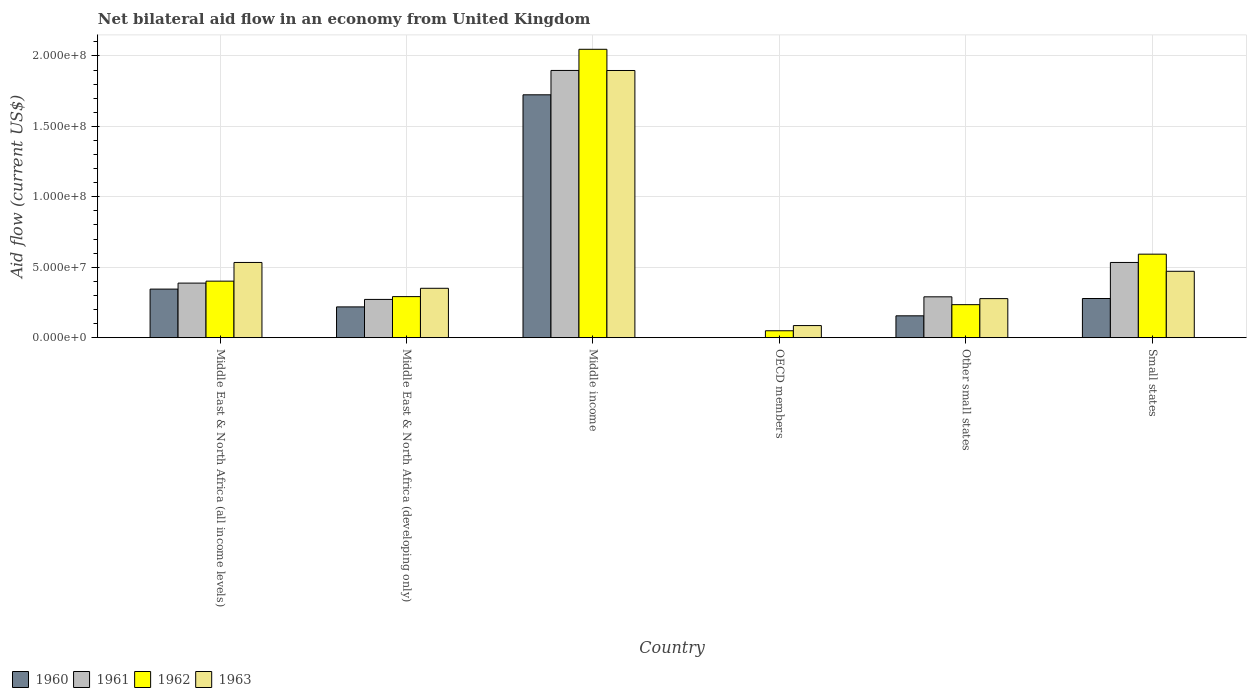How many groups of bars are there?
Offer a very short reply. 6. How many bars are there on the 2nd tick from the left?
Offer a terse response. 4. What is the label of the 4th group of bars from the left?
Your response must be concise. OECD members. In how many cases, is the number of bars for a given country not equal to the number of legend labels?
Make the answer very short. 1. What is the net bilateral aid flow in 1961 in OECD members?
Make the answer very short. 0. Across all countries, what is the maximum net bilateral aid flow in 1961?
Make the answer very short. 1.90e+08. Across all countries, what is the minimum net bilateral aid flow in 1962?
Provide a succinct answer. 4.90e+06. What is the total net bilateral aid flow in 1960 in the graph?
Give a very brief answer. 2.72e+08. What is the difference between the net bilateral aid flow in 1963 in Middle East & North Africa (developing only) and that in Middle income?
Your response must be concise. -1.55e+08. What is the difference between the net bilateral aid flow in 1960 in Middle East & North Africa (all income levels) and the net bilateral aid flow in 1963 in Middle East & North Africa (developing only)?
Your answer should be very brief. -5.80e+05. What is the average net bilateral aid flow in 1960 per country?
Ensure brevity in your answer.  4.53e+07. What is the difference between the net bilateral aid flow of/in 1962 and net bilateral aid flow of/in 1960 in Middle East & North Africa (developing only)?
Offer a terse response. 7.30e+06. What is the ratio of the net bilateral aid flow in 1960 in Middle East & North Africa (all income levels) to that in Other small states?
Your answer should be very brief. 2.22. What is the difference between the highest and the second highest net bilateral aid flow in 1961?
Keep it short and to the point. 1.51e+08. What is the difference between the highest and the lowest net bilateral aid flow in 1962?
Your answer should be compact. 2.00e+08. Is the sum of the net bilateral aid flow in 1963 in Middle income and Small states greater than the maximum net bilateral aid flow in 1961 across all countries?
Your answer should be compact. Yes. Is it the case that in every country, the sum of the net bilateral aid flow in 1963 and net bilateral aid flow in 1961 is greater than the sum of net bilateral aid flow in 1962 and net bilateral aid flow in 1960?
Your answer should be compact. No. How many countries are there in the graph?
Your answer should be compact. 6. What is the difference between two consecutive major ticks on the Y-axis?
Your response must be concise. 5.00e+07. Are the values on the major ticks of Y-axis written in scientific E-notation?
Give a very brief answer. Yes. Does the graph contain any zero values?
Offer a very short reply. Yes. Where does the legend appear in the graph?
Your response must be concise. Bottom left. How are the legend labels stacked?
Offer a very short reply. Horizontal. What is the title of the graph?
Make the answer very short. Net bilateral aid flow in an economy from United Kingdom. Does "1970" appear as one of the legend labels in the graph?
Keep it short and to the point. No. What is the label or title of the Y-axis?
Provide a short and direct response. Aid flow (current US$). What is the Aid flow (current US$) in 1960 in Middle East & North Africa (all income levels)?
Your response must be concise. 3.45e+07. What is the Aid flow (current US$) in 1961 in Middle East & North Africa (all income levels)?
Provide a succinct answer. 3.87e+07. What is the Aid flow (current US$) in 1962 in Middle East & North Africa (all income levels)?
Keep it short and to the point. 4.01e+07. What is the Aid flow (current US$) in 1963 in Middle East & North Africa (all income levels)?
Keep it short and to the point. 5.34e+07. What is the Aid flow (current US$) in 1960 in Middle East & North Africa (developing only)?
Provide a succinct answer. 2.18e+07. What is the Aid flow (current US$) in 1961 in Middle East & North Africa (developing only)?
Your answer should be very brief. 2.72e+07. What is the Aid flow (current US$) of 1962 in Middle East & North Africa (developing only)?
Provide a succinct answer. 2.91e+07. What is the Aid flow (current US$) of 1963 in Middle East & North Africa (developing only)?
Provide a short and direct response. 3.50e+07. What is the Aid flow (current US$) in 1960 in Middle income?
Offer a very short reply. 1.72e+08. What is the Aid flow (current US$) in 1961 in Middle income?
Your response must be concise. 1.90e+08. What is the Aid flow (current US$) of 1962 in Middle income?
Your answer should be very brief. 2.05e+08. What is the Aid flow (current US$) in 1963 in Middle income?
Offer a very short reply. 1.90e+08. What is the Aid flow (current US$) of 1960 in OECD members?
Ensure brevity in your answer.  0. What is the Aid flow (current US$) of 1962 in OECD members?
Offer a terse response. 4.90e+06. What is the Aid flow (current US$) in 1963 in OECD members?
Offer a terse response. 8.59e+06. What is the Aid flow (current US$) in 1960 in Other small states?
Give a very brief answer. 1.55e+07. What is the Aid flow (current US$) of 1961 in Other small states?
Keep it short and to the point. 2.90e+07. What is the Aid flow (current US$) of 1962 in Other small states?
Keep it short and to the point. 2.34e+07. What is the Aid flow (current US$) of 1963 in Other small states?
Give a very brief answer. 2.77e+07. What is the Aid flow (current US$) in 1960 in Small states?
Your response must be concise. 2.78e+07. What is the Aid flow (current US$) of 1961 in Small states?
Your answer should be compact. 5.34e+07. What is the Aid flow (current US$) of 1962 in Small states?
Your response must be concise. 5.93e+07. What is the Aid flow (current US$) of 1963 in Small states?
Your response must be concise. 4.71e+07. Across all countries, what is the maximum Aid flow (current US$) in 1960?
Provide a succinct answer. 1.72e+08. Across all countries, what is the maximum Aid flow (current US$) of 1961?
Your answer should be compact. 1.90e+08. Across all countries, what is the maximum Aid flow (current US$) of 1962?
Your response must be concise. 2.05e+08. Across all countries, what is the maximum Aid flow (current US$) in 1963?
Provide a short and direct response. 1.90e+08. Across all countries, what is the minimum Aid flow (current US$) in 1961?
Keep it short and to the point. 0. Across all countries, what is the minimum Aid flow (current US$) in 1962?
Provide a short and direct response. 4.90e+06. Across all countries, what is the minimum Aid flow (current US$) in 1963?
Make the answer very short. 8.59e+06. What is the total Aid flow (current US$) in 1960 in the graph?
Give a very brief answer. 2.72e+08. What is the total Aid flow (current US$) in 1961 in the graph?
Offer a very short reply. 3.38e+08. What is the total Aid flow (current US$) in 1962 in the graph?
Your answer should be compact. 3.62e+08. What is the total Aid flow (current US$) of 1963 in the graph?
Give a very brief answer. 3.62e+08. What is the difference between the Aid flow (current US$) of 1960 in Middle East & North Africa (all income levels) and that in Middle East & North Africa (developing only)?
Your answer should be very brief. 1.26e+07. What is the difference between the Aid flow (current US$) in 1961 in Middle East & North Africa (all income levels) and that in Middle East & North Africa (developing only)?
Your answer should be very brief. 1.16e+07. What is the difference between the Aid flow (current US$) of 1962 in Middle East & North Africa (all income levels) and that in Middle East & North Africa (developing only)?
Provide a short and direct response. 1.10e+07. What is the difference between the Aid flow (current US$) in 1963 in Middle East & North Africa (all income levels) and that in Middle East & North Africa (developing only)?
Make the answer very short. 1.83e+07. What is the difference between the Aid flow (current US$) in 1960 in Middle East & North Africa (all income levels) and that in Middle income?
Your answer should be very brief. -1.38e+08. What is the difference between the Aid flow (current US$) in 1961 in Middle East & North Africa (all income levels) and that in Middle income?
Offer a terse response. -1.51e+08. What is the difference between the Aid flow (current US$) in 1962 in Middle East & North Africa (all income levels) and that in Middle income?
Offer a terse response. -1.65e+08. What is the difference between the Aid flow (current US$) in 1963 in Middle East & North Africa (all income levels) and that in Middle income?
Your response must be concise. -1.36e+08. What is the difference between the Aid flow (current US$) in 1962 in Middle East & North Africa (all income levels) and that in OECD members?
Offer a terse response. 3.52e+07. What is the difference between the Aid flow (current US$) in 1963 in Middle East & North Africa (all income levels) and that in OECD members?
Your answer should be compact. 4.48e+07. What is the difference between the Aid flow (current US$) in 1960 in Middle East & North Africa (all income levels) and that in Other small states?
Offer a terse response. 1.90e+07. What is the difference between the Aid flow (current US$) in 1961 in Middle East & North Africa (all income levels) and that in Other small states?
Your response must be concise. 9.74e+06. What is the difference between the Aid flow (current US$) of 1962 in Middle East & North Africa (all income levels) and that in Other small states?
Your response must be concise. 1.67e+07. What is the difference between the Aid flow (current US$) in 1963 in Middle East & North Africa (all income levels) and that in Other small states?
Keep it short and to the point. 2.57e+07. What is the difference between the Aid flow (current US$) in 1960 in Middle East & North Africa (all income levels) and that in Small states?
Provide a short and direct response. 6.67e+06. What is the difference between the Aid flow (current US$) of 1961 in Middle East & North Africa (all income levels) and that in Small states?
Give a very brief answer. -1.46e+07. What is the difference between the Aid flow (current US$) of 1962 in Middle East & North Africa (all income levels) and that in Small states?
Make the answer very short. -1.92e+07. What is the difference between the Aid flow (current US$) of 1963 in Middle East & North Africa (all income levels) and that in Small states?
Your response must be concise. 6.26e+06. What is the difference between the Aid flow (current US$) in 1960 in Middle East & North Africa (developing only) and that in Middle income?
Give a very brief answer. -1.51e+08. What is the difference between the Aid flow (current US$) of 1961 in Middle East & North Africa (developing only) and that in Middle income?
Your response must be concise. -1.63e+08. What is the difference between the Aid flow (current US$) of 1962 in Middle East & North Africa (developing only) and that in Middle income?
Offer a very short reply. -1.76e+08. What is the difference between the Aid flow (current US$) in 1963 in Middle East & North Africa (developing only) and that in Middle income?
Offer a very short reply. -1.55e+08. What is the difference between the Aid flow (current US$) of 1962 in Middle East & North Africa (developing only) and that in OECD members?
Provide a succinct answer. 2.42e+07. What is the difference between the Aid flow (current US$) in 1963 in Middle East & North Africa (developing only) and that in OECD members?
Keep it short and to the point. 2.65e+07. What is the difference between the Aid flow (current US$) in 1960 in Middle East & North Africa (developing only) and that in Other small states?
Provide a succinct answer. 6.33e+06. What is the difference between the Aid flow (current US$) in 1961 in Middle East & North Africa (developing only) and that in Other small states?
Your response must be concise. -1.84e+06. What is the difference between the Aid flow (current US$) of 1962 in Middle East & North Africa (developing only) and that in Other small states?
Provide a short and direct response. 5.71e+06. What is the difference between the Aid flow (current US$) of 1963 in Middle East & North Africa (developing only) and that in Other small states?
Give a very brief answer. 7.33e+06. What is the difference between the Aid flow (current US$) of 1960 in Middle East & North Africa (developing only) and that in Small states?
Offer a very short reply. -5.96e+06. What is the difference between the Aid flow (current US$) in 1961 in Middle East & North Africa (developing only) and that in Small states?
Your response must be concise. -2.62e+07. What is the difference between the Aid flow (current US$) of 1962 in Middle East & North Africa (developing only) and that in Small states?
Ensure brevity in your answer.  -3.01e+07. What is the difference between the Aid flow (current US$) in 1963 in Middle East & North Africa (developing only) and that in Small states?
Provide a succinct answer. -1.21e+07. What is the difference between the Aid flow (current US$) in 1962 in Middle income and that in OECD members?
Offer a terse response. 2.00e+08. What is the difference between the Aid flow (current US$) in 1963 in Middle income and that in OECD members?
Your answer should be very brief. 1.81e+08. What is the difference between the Aid flow (current US$) of 1960 in Middle income and that in Other small states?
Ensure brevity in your answer.  1.57e+08. What is the difference between the Aid flow (current US$) in 1961 in Middle income and that in Other small states?
Give a very brief answer. 1.61e+08. What is the difference between the Aid flow (current US$) in 1962 in Middle income and that in Other small states?
Offer a very short reply. 1.81e+08. What is the difference between the Aid flow (current US$) in 1963 in Middle income and that in Other small states?
Keep it short and to the point. 1.62e+08. What is the difference between the Aid flow (current US$) of 1960 in Middle income and that in Small states?
Your answer should be very brief. 1.45e+08. What is the difference between the Aid flow (current US$) of 1961 in Middle income and that in Small states?
Your response must be concise. 1.36e+08. What is the difference between the Aid flow (current US$) in 1962 in Middle income and that in Small states?
Ensure brevity in your answer.  1.45e+08. What is the difference between the Aid flow (current US$) in 1963 in Middle income and that in Small states?
Give a very brief answer. 1.43e+08. What is the difference between the Aid flow (current US$) in 1962 in OECD members and that in Other small states?
Offer a very short reply. -1.85e+07. What is the difference between the Aid flow (current US$) in 1963 in OECD members and that in Other small states?
Keep it short and to the point. -1.91e+07. What is the difference between the Aid flow (current US$) of 1962 in OECD members and that in Small states?
Provide a succinct answer. -5.44e+07. What is the difference between the Aid flow (current US$) of 1963 in OECD members and that in Small states?
Your answer should be compact. -3.85e+07. What is the difference between the Aid flow (current US$) of 1960 in Other small states and that in Small states?
Provide a short and direct response. -1.23e+07. What is the difference between the Aid flow (current US$) in 1961 in Other small states and that in Small states?
Ensure brevity in your answer.  -2.44e+07. What is the difference between the Aid flow (current US$) of 1962 in Other small states and that in Small states?
Provide a short and direct response. -3.58e+07. What is the difference between the Aid flow (current US$) of 1963 in Other small states and that in Small states?
Provide a short and direct response. -1.94e+07. What is the difference between the Aid flow (current US$) in 1960 in Middle East & North Africa (all income levels) and the Aid flow (current US$) in 1961 in Middle East & North Africa (developing only)?
Provide a short and direct response. 7.32e+06. What is the difference between the Aid flow (current US$) in 1960 in Middle East & North Africa (all income levels) and the Aid flow (current US$) in 1962 in Middle East & North Africa (developing only)?
Offer a terse response. 5.33e+06. What is the difference between the Aid flow (current US$) of 1960 in Middle East & North Africa (all income levels) and the Aid flow (current US$) of 1963 in Middle East & North Africa (developing only)?
Your answer should be very brief. -5.80e+05. What is the difference between the Aid flow (current US$) in 1961 in Middle East & North Africa (all income levels) and the Aid flow (current US$) in 1962 in Middle East & North Africa (developing only)?
Ensure brevity in your answer.  9.59e+06. What is the difference between the Aid flow (current US$) in 1961 in Middle East & North Africa (all income levels) and the Aid flow (current US$) in 1963 in Middle East & North Africa (developing only)?
Keep it short and to the point. 3.68e+06. What is the difference between the Aid flow (current US$) in 1962 in Middle East & North Africa (all income levels) and the Aid flow (current US$) in 1963 in Middle East & North Africa (developing only)?
Provide a succinct answer. 5.07e+06. What is the difference between the Aid flow (current US$) in 1960 in Middle East & North Africa (all income levels) and the Aid flow (current US$) in 1961 in Middle income?
Provide a succinct answer. -1.55e+08. What is the difference between the Aid flow (current US$) in 1960 in Middle East & North Africa (all income levels) and the Aid flow (current US$) in 1962 in Middle income?
Provide a succinct answer. -1.70e+08. What is the difference between the Aid flow (current US$) of 1960 in Middle East & North Africa (all income levels) and the Aid flow (current US$) of 1963 in Middle income?
Offer a very short reply. -1.55e+08. What is the difference between the Aid flow (current US$) in 1961 in Middle East & North Africa (all income levels) and the Aid flow (current US$) in 1962 in Middle income?
Your answer should be compact. -1.66e+08. What is the difference between the Aid flow (current US$) in 1961 in Middle East & North Africa (all income levels) and the Aid flow (current US$) in 1963 in Middle income?
Your response must be concise. -1.51e+08. What is the difference between the Aid flow (current US$) in 1962 in Middle East & North Africa (all income levels) and the Aid flow (current US$) in 1963 in Middle income?
Provide a succinct answer. -1.50e+08. What is the difference between the Aid flow (current US$) in 1960 in Middle East & North Africa (all income levels) and the Aid flow (current US$) in 1962 in OECD members?
Give a very brief answer. 2.96e+07. What is the difference between the Aid flow (current US$) of 1960 in Middle East & North Africa (all income levels) and the Aid flow (current US$) of 1963 in OECD members?
Offer a very short reply. 2.59e+07. What is the difference between the Aid flow (current US$) of 1961 in Middle East & North Africa (all income levels) and the Aid flow (current US$) of 1962 in OECD members?
Provide a succinct answer. 3.38e+07. What is the difference between the Aid flow (current US$) in 1961 in Middle East & North Africa (all income levels) and the Aid flow (current US$) in 1963 in OECD members?
Keep it short and to the point. 3.01e+07. What is the difference between the Aid flow (current US$) in 1962 in Middle East & North Africa (all income levels) and the Aid flow (current US$) in 1963 in OECD members?
Ensure brevity in your answer.  3.15e+07. What is the difference between the Aid flow (current US$) of 1960 in Middle East & North Africa (all income levels) and the Aid flow (current US$) of 1961 in Other small states?
Provide a short and direct response. 5.48e+06. What is the difference between the Aid flow (current US$) in 1960 in Middle East & North Africa (all income levels) and the Aid flow (current US$) in 1962 in Other small states?
Offer a very short reply. 1.10e+07. What is the difference between the Aid flow (current US$) of 1960 in Middle East & North Africa (all income levels) and the Aid flow (current US$) of 1963 in Other small states?
Keep it short and to the point. 6.75e+06. What is the difference between the Aid flow (current US$) of 1961 in Middle East & North Africa (all income levels) and the Aid flow (current US$) of 1962 in Other small states?
Your answer should be very brief. 1.53e+07. What is the difference between the Aid flow (current US$) of 1961 in Middle East & North Africa (all income levels) and the Aid flow (current US$) of 1963 in Other small states?
Ensure brevity in your answer.  1.10e+07. What is the difference between the Aid flow (current US$) of 1962 in Middle East & North Africa (all income levels) and the Aid flow (current US$) of 1963 in Other small states?
Your answer should be very brief. 1.24e+07. What is the difference between the Aid flow (current US$) of 1960 in Middle East & North Africa (all income levels) and the Aid flow (current US$) of 1961 in Small states?
Provide a short and direct response. -1.89e+07. What is the difference between the Aid flow (current US$) of 1960 in Middle East & North Africa (all income levels) and the Aid flow (current US$) of 1962 in Small states?
Your answer should be compact. -2.48e+07. What is the difference between the Aid flow (current US$) of 1960 in Middle East & North Africa (all income levels) and the Aid flow (current US$) of 1963 in Small states?
Offer a terse response. -1.26e+07. What is the difference between the Aid flow (current US$) of 1961 in Middle East & North Africa (all income levels) and the Aid flow (current US$) of 1962 in Small states?
Provide a succinct answer. -2.05e+07. What is the difference between the Aid flow (current US$) of 1961 in Middle East & North Africa (all income levels) and the Aid flow (current US$) of 1963 in Small states?
Keep it short and to the point. -8.39e+06. What is the difference between the Aid flow (current US$) in 1962 in Middle East & North Africa (all income levels) and the Aid flow (current US$) in 1963 in Small states?
Offer a terse response. -7.00e+06. What is the difference between the Aid flow (current US$) in 1960 in Middle East & North Africa (developing only) and the Aid flow (current US$) in 1961 in Middle income?
Ensure brevity in your answer.  -1.68e+08. What is the difference between the Aid flow (current US$) in 1960 in Middle East & North Africa (developing only) and the Aid flow (current US$) in 1962 in Middle income?
Your answer should be compact. -1.83e+08. What is the difference between the Aid flow (current US$) in 1960 in Middle East & North Africa (developing only) and the Aid flow (current US$) in 1963 in Middle income?
Your answer should be compact. -1.68e+08. What is the difference between the Aid flow (current US$) in 1961 in Middle East & North Africa (developing only) and the Aid flow (current US$) in 1962 in Middle income?
Ensure brevity in your answer.  -1.78e+08. What is the difference between the Aid flow (current US$) in 1961 in Middle East & North Africa (developing only) and the Aid flow (current US$) in 1963 in Middle income?
Offer a very short reply. -1.63e+08. What is the difference between the Aid flow (current US$) of 1962 in Middle East & North Africa (developing only) and the Aid flow (current US$) of 1963 in Middle income?
Give a very brief answer. -1.61e+08. What is the difference between the Aid flow (current US$) in 1960 in Middle East & North Africa (developing only) and the Aid flow (current US$) in 1962 in OECD members?
Provide a succinct answer. 1.69e+07. What is the difference between the Aid flow (current US$) in 1960 in Middle East & North Africa (developing only) and the Aid flow (current US$) in 1963 in OECD members?
Your response must be concise. 1.32e+07. What is the difference between the Aid flow (current US$) in 1961 in Middle East & North Africa (developing only) and the Aid flow (current US$) in 1962 in OECD members?
Your answer should be very brief. 2.22e+07. What is the difference between the Aid flow (current US$) of 1961 in Middle East & North Africa (developing only) and the Aid flow (current US$) of 1963 in OECD members?
Your answer should be very brief. 1.86e+07. What is the difference between the Aid flow (current US$) in 1962 in Middle East & North Africa (developing only) and the Aid flow (current US$) in 1963 in OECD members?
Provide a short and direct response. 2.06e+07. What is the difference between the Aid flow (current US$) in 1960 in Middle East & North Africa (developing only) and the Aid flow (current US$) in 1961 in Other small states?
Make the answer very short. -7.15e+06. What is the difference between the Aid flow (current US$) in 1960 in Middle East & North Africa (developing only) and the Aid flow (current US$) in 1962 in Other small states?
Provide a succinct answer. -1.59e+06. What is the difference between the Aid flow (current US$) in 1960 in Middle East & North Africa (developing only) and the Aid flow (current US$) in 1963 in Other small states?
Provide a short and direct response. -5.88e+06. What is the difference between the Aid flow (current US$) in 1961 in Middle East & North Africa (developing only) and the Aid flow (current US$) in 1962 in Other small states?
Keep it short and to the point. 3.72e+06. What is the difference between the Aid flow (current US$) in 1961 in Middle East & North Africa (developing only) and the Aid flow (current US$) in 1963 in Other small states?
Your response must be concise. -5.70e+05. What is the difference between the Aid flow (current US$) of 1962 in Middle East & North Africa (developing only) and the Aid flow (current US$) of 1963 in Other small states?
Provide a succinct answer. 1.42e+06. What is the difference between the Aid flow (current US$) in 1960 in Middle East & North Africa (developing only) and the Aid flow (current US$) in 1961 in Small states?
Give a very brief answer. -3.15e+07. What is the difference between the Aid flow (current US$) of 1960 in Middle East & North Africa (developing only) and the Aid flow (current US$) of 1962 in Small states?
Provide a short and direct response. -3.74e+07. What is the difference between the Aid flow (current US$) of 1960 in Middle East & North Africa (developing only) and the Aid flow (current US$) of 1963 in Small states?
Give a very brief answer. -2.53e+07. What is the difference between the Aid flow (current US$) in 1961 in Middle East & North Africa (developing only) and the Aid flow (current US$) in 1962 in Small states?
Give a very brief answer. -3.21e+07. What is the difference between the Aid flow (current US$) of 1961 in Middle East & North Africa (developing only) and the Aid flow (current US$) of 1963 in Small states?
Make the answer very short. -2.00e+07. What is the difference between the Aid flow (current US$) of 1962 in Middle East & North Africa (developing only) and the Aid flow (current US$) of 1963 in Small states?
Offer a very short reply. -1.80e+07. What is the difference between the Aid flow (current US$) in 1960 in Middle income and the Aid flow (current US$) in 1962 in OECD members?
Ensure brevity in your answer.  1.68e+08. What is the difference between the Aid flow (current US$) of 1960 in Middle income and the Aid flow (current US$) of 1963 in OECD members?
Your answer should be compact. 1.64e+08. What is the difference between the Aid flow (current US$) of 1961 in Middle income and the Aid flow (current US$) of 1962 in OECD members?
Offer a terse response. 1.85e+08. What is the difference between the Aid flow (current US$) of 1961 in Middle income and the Aid flow (current US$) of 1963 in OECD members?
Make the answer very short. 1.81e+08. What is the difference between the Aid flow (current US$) in 1962 in Middle income and the Aid flow (current US$) in 1963 in OECD members?
Keep it short and to the point. 1.96e+08. What is the difference between the Aid flow (current US$) of 1960 in Middle income and the Aid flow (current US$) of 1961 in Other small states?
Your response must be concise. 1.43e+08. What is the difference between the Aid flow (current US$) in 1960 in Middle income and the Aid flow (current US$) in 1962 in Other small states?
Provide a succinct answer. 1.49e+08. What is the difference between the Aid flow (current US$) in 1960 in Middle income and the Aid flow (current US$) in 1963 in Other small states?
Give a very brief answer. 1.45e+08. What is the difference between the Aid flow (current US$) of 1961 in Middle income and the Aid flow (current US$) of 1962 in Other small states?
Provide a succinct answer. 1.66e+08. What is the difference between the Aid flow (current US$) of 1961 in Middle income and the Aid flow (current US$) of 1963 in Other small states?
Ensure brevity in your answer.  1.62e+08. What is the difference between the Aid flow (current US$) of 1962 in Middle income and the Aid flow (current US$) of 1963 in Other small states?
Your answer should be compact. 1.77e+08. What is the difference between the Aid flow (current US$) of 1960 in Middle income and the Aid flow (current US$) of 1961 in Small states?
Give a very brief answer. 1.19e+08. What is the difference between the Aid flow (current US$) of 1960 in Middle income and the Aid flow (current US$) of 1962 in Small states?
Keep it short and to the point. 1.13e+08. What is the difference between the Aid flow (current US$) of 1960 in Middle income and the Aid flow (current US$) of 1963 in Small states?
Offer a very short reply. 1.25e+08. What is the difference between the Aid flow (current US$) of 1961 in Middle income and the Aid flow (current US$) of 1962 in Small states?
Ensure brevity in your answer.  1.30e+08. What is the difference between the Aid flow (current US$) of 1961 in Middle income and the Aid flow (current US$) of 1963 in Small states?
Keep it short and to the point. 1.43e+08. What is the difference between the Aid flow (current US$) in 1962 in Middle income and the Aid flow (current US$) in 1963 in Small states?
Offer a terse response. 1.58e+08. What is the difference between the Aid flow (current US$) in 1962 in OECD members and the Aid flow (current US$) in 1963 in Other small states?
Provide a short and direct response. -2.28e+07. What is the difference between the Aid flow (current US$) of 1962 in OECD members and the Aid flow (current US$) of 1963 in Small states?
Make the answer very short. -4.22e+07. What is the difference between the Aid flow (current US$) of 1960 in Other small states and the Aid flow (current US$) of 1961 in Small states?
Make the answer very short. -3.79e+07. What is the difference between the Aid flow (current US$) in 1960 in Other small states and the Aid flow (current US$) in 1962 in Small states?
Give a very brief answer. -4.38e+07. What is the difference between the Aid flow (current US$) of 1960 in Other small states and the Aid flow (current US$) of 1963 in Small states?
Give a very brief answer. -3.16e+07. What is the difference between the Aid flow (current US$) in 1961 in Other small states and the Aid flow (current US$) in 1962 in Small states?
Offer a terse response. -3.03e+07. What is the difference between the Aid flow (current US$) in 1961 in Other small states and the Aid flow (current US$) in 1963 in Small states?
Your answer should be compact. -1.81e+07. What is the difference between the Aid flow (current US$) of 1962 in Other small states and the Aid flow (current US$) of 1963 in Small states?
Offer a very short reply. -2.37e+07. What is the average Aid flow (current US$) of 1960 per country?
Your answer should be compact. 4.53e+07. What is the average Aid flow (current US$) in 1961 per country?
Keep it short and to the point. 5.63e+07. What is the average Aid flow (current US$) of 1962 per country?
Ensure brevity in your answer.  6.03e+07. What is the average Aid flow (current US$) of 1963 per country?
Keep it short and to the point. 6.03e+07. What is the difference between the Aid flow (current US$) in 1960 and Aid flow (current US$) in 1961 in Middle East & North Africa (all income levels)?
Provide a succinct answer. -4.26e+06. What is the difference between the Aid flow (current US$) in 1960 and Aid flow (current US$) in 1962 in Middle East & North Africa (all income levels)?
Your answer should be compact. -5.65e+06. What is the difference between the Aid flow (current US$) of 1960 and Aid flow (current US$) of 1963 in Middle East & North Africa (all income levels)?
Offer a terse response. -1.89e+07. What is the difference between the Aid flow (current US$) in 1961 and Aid flow (current US$) in 1962 in Middle East & North Africa (all income levels)?
Keep it short and to the point. -1.39e+06. What is the difference between the Aid flow (current US$) in 1961 and Aid flow (current US$) in 1963 in Middle East & North Africa (all income levels)?
Your response must be concise. -1.46e+07. What is the difference between the Aid flow (current US$) of 1962 and Aid flow (current US$) of 1963 in Middle East & North Africa (all income levels)?
Give a very brief answer. -1.33e+07. What is the difference between the Aid flow (current US$) of 1960 and Aid flow (current US$) of 1961 in Middle East & North Africa (developing only)?
Offer a terse response. -5.31e+06. What is the difference between the Aid flow (current US$) in 1960 and Aid flow (current US$) in 1962 in Middle East & North Africa (developing only)?
Keep it short and to the point. -7.30e+06. What is the difference between the Aid flow (current US$) of 1960 and Aid flow (current US$) of 1963 in Middle East & North Africa (developing only)?
Make the answer very short. -1.32e+07. What is the difference between the Aid flow (current US$) of 1961 and Aid flow (current US$) of 1962 in Middle East & North Africa (developing only)?
Offer a very short reply. -1.99e+06. What is the difference between the Aid flow (current US$) of 1961 and Aid flow (current US$) of 1963 in Middle East & North Africa (developing only)?
Provide a succinct answer. -7.90e+06. What is the difference between the Aid flow (current US$) in 1962 and Aid flow (current US$) in 1963 in Middle East & North Africa (developing only)?
Give a very brief answer. -5.91e+06. What is the difference between the Aid flow (current US$) in 1960 and Aid flow (current US$) in 1961 in Middle income?
Provide a short and direct response. -1.73e+07. What is the difference between the Aid flow (current US$) in 1960 and Aid flow (current US$) in 1962 in Middle income?
Your answer should be very brief. -3.23e+07. What is the difference between the Aid flow (current US$) in 1960 and Aid flow (current US$) in 1963 in Middle income?
Keep it short and to the point. -1.73e+07. What is the difference between the Aid flow (current US$) in 1961 and Aid flow (current US$) in 1962 in Middle income?
Offer a terse response. -1.50e+07. What is the difference between the Aid flow (current US$) in 1961 and Aid flow (current US$) in 1963 in Middle income?
Make the answer very short. 3.00e+04. What is the difference between the Aid flow (current US$) in 1962 and Aid flow (current US$) in 1963 in Middle income?
Your response must be concise. 1.50e+07. What is the difference between the Aid flow (current US$) of 1962 and Aid flow (current US$) of 1963 in OECD members?
Make the answer very short. -3.69e+06. What is the difference between the Aid flow (current US$) of 1960 and Aid flow (current US$) of 1961 in Other small states?
Make the answer very short. -1.35e+07. What is the difference between the Aid flow (current US$) of 1960 and Aid flow (current US$) of 1962 in Other small states?
Give a very brief answer. -7.92e+06. What is the difference between the Aid flow (current US$) in 1960 and Aid flow (current US$) in 1963 in Other small states?
Make the answer very short. -1.22e+07. What is the difference between the Aid flow (current US$) of 1961 and Aid flow (current US$) of 1962 in Other small states?
Offer a terse response. 5.56e+06. What is the difference between the Aid flow (current US$) of 1961 and Aid flow (current US$) of 1963 in Other small states?
Your response must be concise. 1.27e+06. What is the difference between the Aid flow (current US$) in 1962 and Aid flow (current US$) in 1963 in Other small states?
Offer a terse response. -4.29e+06. What is the difference between the Aid flow (current US$) of 1960 and Aid flow (current US$) of 1961 in Small states?
Your response must be concise. -2.56e+07. What is the difference between the Aid flow (current US$) of 1960 and Aid flow (current US$) of 1962 in Small states?
Ensure brevity in your answer.  -3.15e+07. What is the difference between the Aid flow (current US$) of 1960 and Aid flow (current US$) of 1963 in Small states?
Your response must be concise. -1.93e+07. What is the difference between the Aid flow (current US$) in 1961 and Aid flow (current US$) in 1962 in Small states?
Provide a short and direct response. -5.89e+06. What is the difference between the Aid flow (current US$) in 1961 and Aid flow (current US$) in 1963 in Small states?
Offer a very short reply. 6.26e+06. What is the difference between the Aid flow (current US$) of 1962 and Aid flow (current US$) of 1963 in Small states?
Provide a succinct answer. 1.22e+07. What is the ratio of the Aid flow (current US$) of 1960 in Middle East & North Africa (all income levels) to that in Middle East & North Africa (developing only)?
Provide a succinct answer. 1.58. What is the ratio of the Aid flow (current US$) in 1961 in Middle East & North Africa (all income levels) to that in Middle East & North Africa (developing only)?
Your answer should be very brief. 1.43. What is the ratio of the Aid flow (current US$) of 1962 in Middle East & North Africa (all income levels) to that in Middle East & North Africa (developing only)?
Make the answer very short. 1.38. What is the ratio of the Aid flow (current US$) in 1963 in Middle East & North Africa (all income levels) to that in Middle East & North Africa (developing only)?
Your answer should be very brief. 1.52. What is the ratio of the Aid flow (current US$) in 1960 in Middle East & North Africa (all income levels) to that in Middle income?
Your answer should be very brief. 0.2. What is the ratio of the Aid flow (current US$) in 1961 in Middle East & North Africa (all income levels) to that in Middle income?
Ensure brevity in your answer.  0.2. What is the ratio of the Aid flow (current US$) in 1962 in Middle East & North Africa (all income levels) to that in Middle income?
Offer a very short reply. 0.2. What is the ratio of the Aid flow (current US$) of 1963 in Middle East & North Africa (all income levels) to that in Middle income?
Provide a succinct answer. 0.28. What is the ratio of the Aid flow (current US$) in 1962 in Middle East & North Africa (all income levels) to that in OECD members?
Provide a short and direct response. 8.19. What is the ratio of the Aid flow (current US$) in 1963 in Middle East & North Africa (all income levels) to that in OECD members?
Make the answer very short. 6.21. What is the ratio of the Aid flow (current US$) of 1960 in Middle East & North Africa (all income levels) to that in Other small states?
Offer a terse response. 2.22. What is the ratio of the Aid flow (current US$) in 1961 in Middle East & North Africa (all income levels) to that in Other small states?
Make the answer very short. 1.34. What is the ratio of the Aid flow (current US$) of 1962 in Middle East & North Africa (all income levels) to that in Other small states?
Your response must be concise. 1.71. What is the ratio of the Aid flow (current US$) in 1963 in Middle East & North Africa (all income levels) to that in Other small states?
Offer a very short reply. 1.93. What is the ratio of the Aid flow (current US$) in 1960 in Middle East & North Africa (all income levels) to that in Small states?
Provide a succinct answer. 1.24. What is the ratio of the Aid flow (current US$) in 1961 in Middle East & North Africa (all income levels) to that in Small states?
Keep it short and to the point. 0.73. What is the ratio of the Aid flow (current US$) in 1962 in Middle East & North Africa (all income levels) to that in Small states?
Keep it short and to the point. 0.68. What is the ratio of the Aid flow (current US$) of 1963 in Middle East & North Africa (all income levels) to that in Small states?
Make the answer very short. 1.13. What is the ratio of the Aid flow (current US$) in 1960 in Middle East & North Africa (developing only) to that in Middle income?
Your answer should be very brief. 0.13. What is the ratio of the Aid flow (current US$) of 1961 in Middle East & North Africa (developing only) to that in Middle income?
Offer a terse response. 0.14. What is the ratio of the Aid flow (current US$) of 1962 in Middle East & North Africa (developing only) to that in Middle income?
Provide a succinct answer. 0.14. What is the ratio of the Aid flow (current US$) in 1963 in Middle East & North Africa (developing only) to that in Middle income?
Provide a succinct answer. 0.18. What is the ratio of the Aid flow (current US$) of 1962 in Middle East & North Africa (developing only) to that in OECD members?
Make the answer very short. 5.95. What is the ratio of the Aid flow (current US$) in 1963 in Middle East & North Africa (developing only) to that in OECD members?
Your answer should be compact. 4.08. What is the ratio of the Aid flow (current US$) in 1960 in Middle East & North Africa (developing only) to that in Other small states?
Offer a very short reply. 1.41. What is the ratio of the Aid flow (current US$) in 1961 in Middle East & North Africa (developing only) to that in Other small states?
Give a very brief answer. 0.94. What is the ratio of the Aid flow (current US$) in 1962 in Middle East & North Africa (developing only) to that in Other small states?
Offer a very short reply. 1.24. What is the ratio of the Aid flow (current US$) of 1963 in Middle East & North Africa (developing only) to that in Other small states?
Offer a terse response. 1.26. What is the ratio of the Aid flow (current US$) of 1960 in Middle East & North Africa (developing only) to that in Small states?
Your answer should be very brief. 0.79. What is the ratio of the Aid flow (current US$) in 1961 in Middle East & North Africa (developing only) to that in Small states?
Give a very brief answer. 0.51. What is the ratio of the Aid flow (current US$) in 1962 in Middle East & North Africa (developing only) to that in Small states?
Your answer should be compact. 0.49. What is the ratio of the Aid flow (current US$) in 1963 in Middle East & North Africa (developing only) to that in Small states?
Offer a terse response. 0.74. What is the ratio of the Aid flow (current US$) in 1962 in Middle income to that in OECD members?
Ensure brevity in your answer.  41.78. What is the ratio of the Aid flow (current US$) of 1963 in Middle income to that in OECD members?
Give a very brief answer. 22.08. What is the ratio of the Aid flow (current US$) of 1960 in Middle income to that in Other small states?
Give a very brief answer. 11.12. What is the ratio of the Aid flow (current US$) of 1961 in Middle income to that in Other small states?
Provide a short and direct response. 6.54. What is the ratio of the Aid flow (current US$) in 1962 in Middle income to that in Other small states?
Keep it short and to the point. 8.74. What is the ratio of the Aid flow (current US$) in 1963 in Middle income to that in Other small states?
Your answer should be very brief. 6.84. What is the ratio of the Aid flow (current US$) in 1960 in Middle income to that in Small states?
Give a very brief answer. 6.2. What is the ratio of the Aid flow (current US$) of 1961 in Middle income to that in Small states?
Keep it short and to the point. 3.55. What is the ratio of the Aid flow (current US$) in 1962 in Middle income to that in Small states?
Make the answer very short. 3.45. What is the ratio of the Aid flow (current US$) of 1963 in Middle income to that in Small states?
Offer a terse response. 4.03. What is the ratio of the Aid flow (current US$) of 1962 in OECD members to that in Other small states?
Give a very brief answer. 0.21. What is the ratio of the Aid flow (current US$) in 1963 in OECD members to that in Other small states?
Give a very brief answer. 0.31. What is the ratio of the Aid flow (current US$) in 1962 in OECD members to that in Small states?
Give a very brief answer. 0.08. What is the ratio of the Aid flow (current US$) of 1963 in OECD members to that in Small states?
Give a very brief answer. 0.18. What is the ratio of the Aid flow (current US$) of 1960 in Other small states to that in Small states?
Give a very brief answer. 0.56. What is the ratio of the Aid flow (current US$) of 1961 in Other small states to that in Small states?
Offer a terse response. 0.54. What is the ratio of the Aid flow (current US$) of 1962 in Other small states to that in Small states?
Your answer should be compact. 0.4. What is the ratio of the Aid flow (current US$) of 1963 in Other small states to that in Small states?
Provide a short and direct response. 0.59. What is the difference between the highest and the second highest Aid flow (current US$) in 1960?
Provide a short and direct response. 1.38e+08. What is the difference between the highest and the second highest Aid flow (current US$) in 1961?
Offer a terse response. 1.36e+08. What is the difference between the highest and the second highest Aid flow (current US$) in 1962?
Offer a very short reply. 1.45e+08. What is the difference between the highest and the second highest Aid flow (current US$) in 1963?
Keep it short and to the point. 1.36e+08. What is the difference between the highest and the lowest Aid flow (current US$) in 1960?
Provide a succinct answer. 1.72e+08. What is the difference between the highest and the lowest Aid flow (current US$) in 1961?
Your answer should be very brief. 1.90e+08. What is the difference between the highest and the lowest Aid flow (current US$) in 1962?
Make the answer very short. 2.00e+08. What is the difference between the highest and the lowest Aid flow (current US$) of 1963?
Your answer should be very brief. 1.81e+08. 